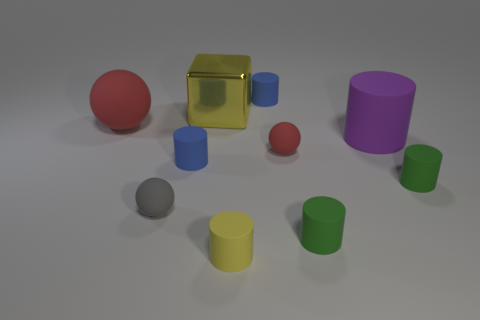Do the yellow matte thing and the gray rubber object have the same size?
Make the answer very short. Yes. How many things are either tiny blue cylinders that are on the left side of the large yellow shiny object or big rubber things on the right side of the big red object?
Provide a succinct answer. 2. What is the material of the green thing in front of the tiny gray sphere that is in front of the tiny red sphere?
Keep it short and to the point. Rubber. How many other objects are the same material as the tiny yellow cylinder?
Your answer should be compact. 8. Is the shape of the gray rubber object the same as the tiny red rubber object?
Your answer should be very brief. Yes. There is a ball that is in front of the small red ball; how big is it?
Your response must be concise. Small. There is a purple rubber thing; is it the same size as the red rubber object behind the large purple rubber object?
Provide a short and direct response. Yes. Is the number of tiny balls that are in front of the small gray rubber object less than the number of tiny rubber balls?
Provide a succinct answer. Yes. There is a purple object that is the same shape as the small yellow object; what is it made of?
Keep it short and to the point. Rubber. What shape is the matte thing that is both behind the big cylinder and to the left of the yellow matte thing?
Your answer should be compact. Sphere. 